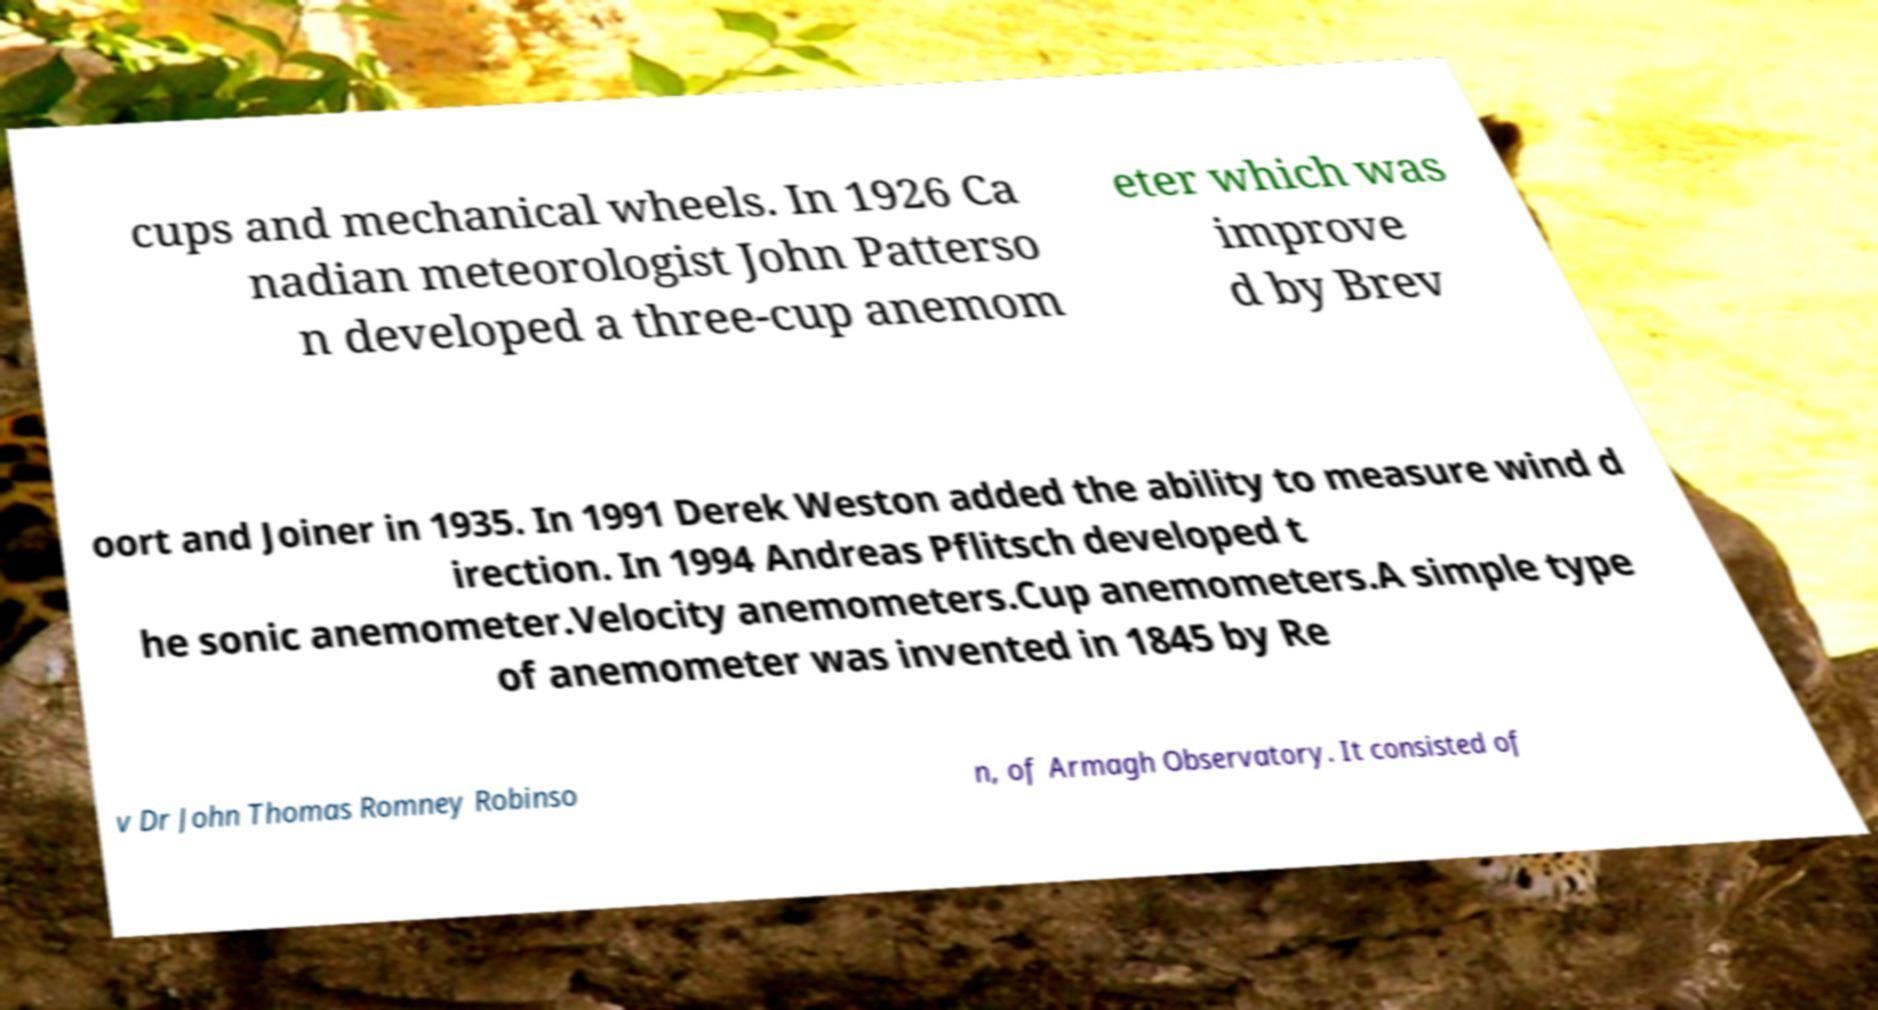For documentation purposes, I need the text within this image transcribed. Could you provide that? cups and mechanical wheels. In 1926 Ca nadian meteorologist John Patterso n developed a three-cup anemom eter which was improve d by Brev oort and Joiner in 1935. In 1991 Derek Weston added the ability to measure wind d irection. In 1994 Andreas Pflitsch developed t he sonic anemometer.Velocity anemometers.Cup anemometers.A simple type of anemometer was invented in 1845 by Re v Dr John Thomas Romney Robinso n, of Armagh Observatory. It consisted of 